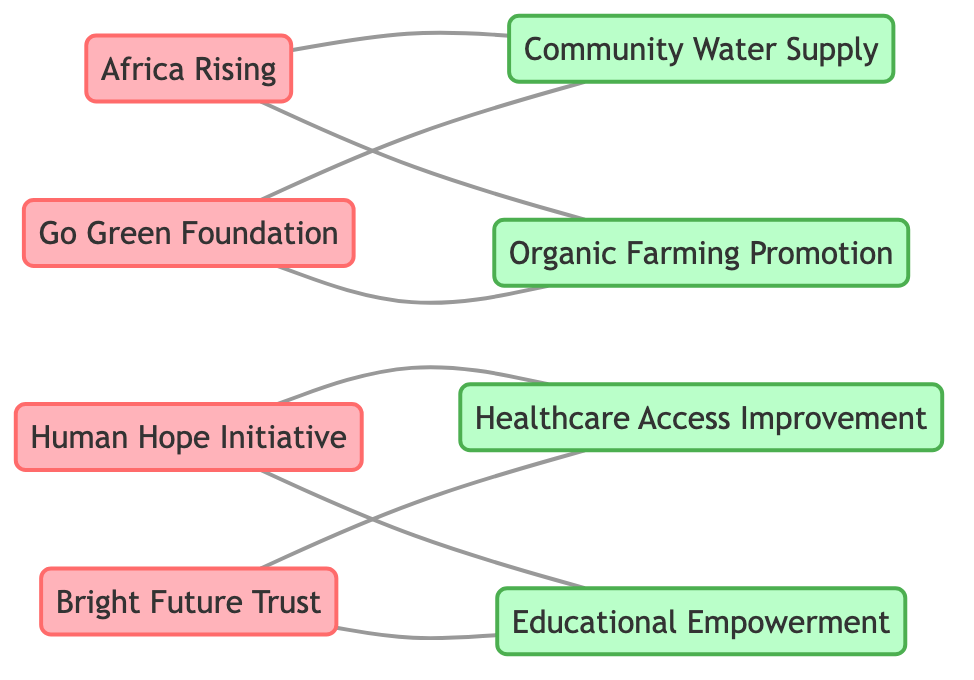What is the total number of NGOs represented in the diagram? There are four unique nodes identified as NGOs: Africa Rising, Go Green Foundation, Human Hope Initiative, and Bright Future Trust. Counting these gives a total of 4 NGOs.
Answer: 4 Which NGO is connected to the Community Water Supply project? Two NGOs, Africa Rising and Go Green Foundation, are directly linked to the Community Water Supply project, indicating they are both involved in it.
Answer: Africa Rising, Go Green Foundation How many projects are listed in the diagram? The diagram contains four distinct projects represented by nodes: Community Water Supply, Organic Farming Promotion, Healthcare Access Improvement, and Educational Empowerment. Therefore, the total number of projects is 4.
Answer: 4 What is the relationship between Human Hope Initiative and Educational Empowerment? The relation is direct; Human Hope Initiative has a connection to the Educational Empowerment project shown in the diagram. This indicates collaboration in this specific project.
Answer: Collaborate Which project has the highest number of NGO connections? The Educational Empowerment project is associated with two NGOs: Human Hope Initiative and Bright Future Trust, making it one of the most connected projects alongside Healthcare Access Improvement, which also has two NGO connections.
Answer: Both Educational Empowerment and Healthcare Access Improvement How many edges are present in the diagram? Edges indicate relationships or connections between the NGOs and projects. Counting all the connections in the provided data, there are a total of 8 edges drawn between the nodes.
Answer: 8 Which NGO is involved in Organic Farming Promotion? Africa Rising and Go Green Foundation are both directly linked to the Organic Farming Promotion project, showing their involvement in this initiative.
Answer: Africa Rising, Go Green Foundation Is there any NGO working on only one project? Yes, the Human Hope Initiative is connected to Healthcare Access Improvement and Educational Empowerment, while Africa Rising and Go Green Foundation work on both Community Water Supply and Organic Farming Promotion. So, no NGO works on only one project.
Answer: No Which two NGOs are focusing on Healthcare Access Improvement? Bright Future Trust and Human Hope Initiative are both directly linked to the Healthcare Access Improvement project, indicating that they are collaborating in this effort.
Answer: Bright Future Trust, Human Hope Initiative 